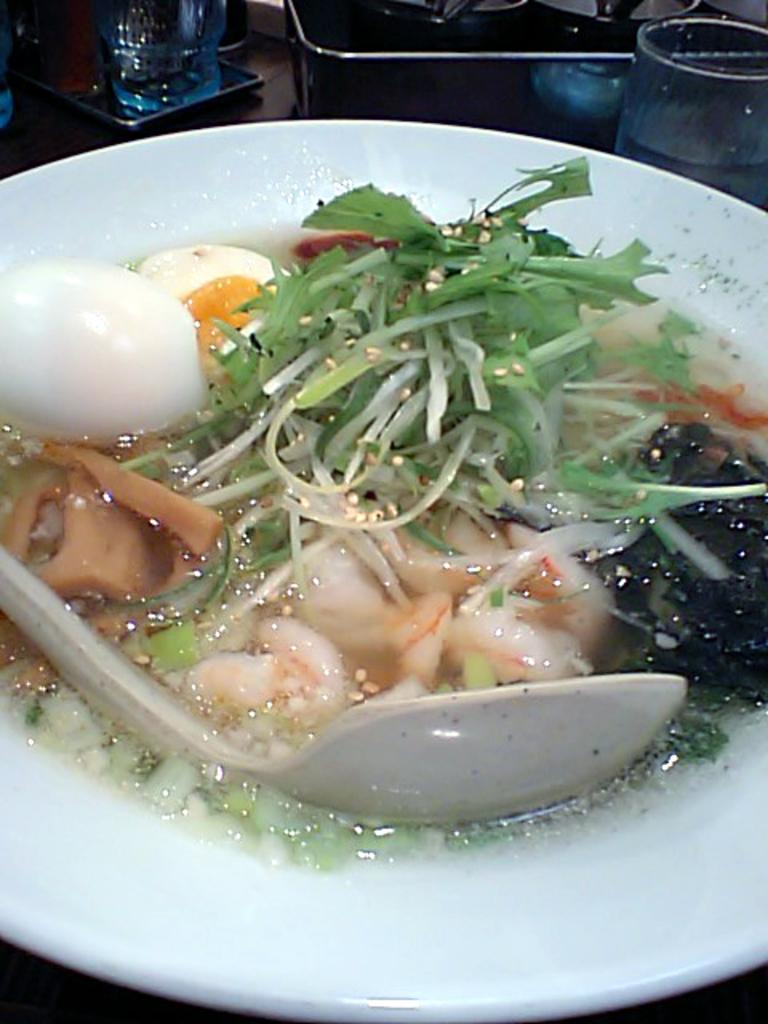What is on the table in the image? There is a plate, glasses, trays, a spoon, and a few other objects on the table. What is on the plate? There are food items on the plate. How many glasses are on the table? There are glasses on the table. What type of utensil is on the table? There is a spoon on the table. What other objects can be seen on the table? There are a few other objects on the table. What type of ring can be seen on the bikes in the image? There are no bikes or rings present in the image. What day of the week is depicted in the image? The image does not depict a specific day of the week. 